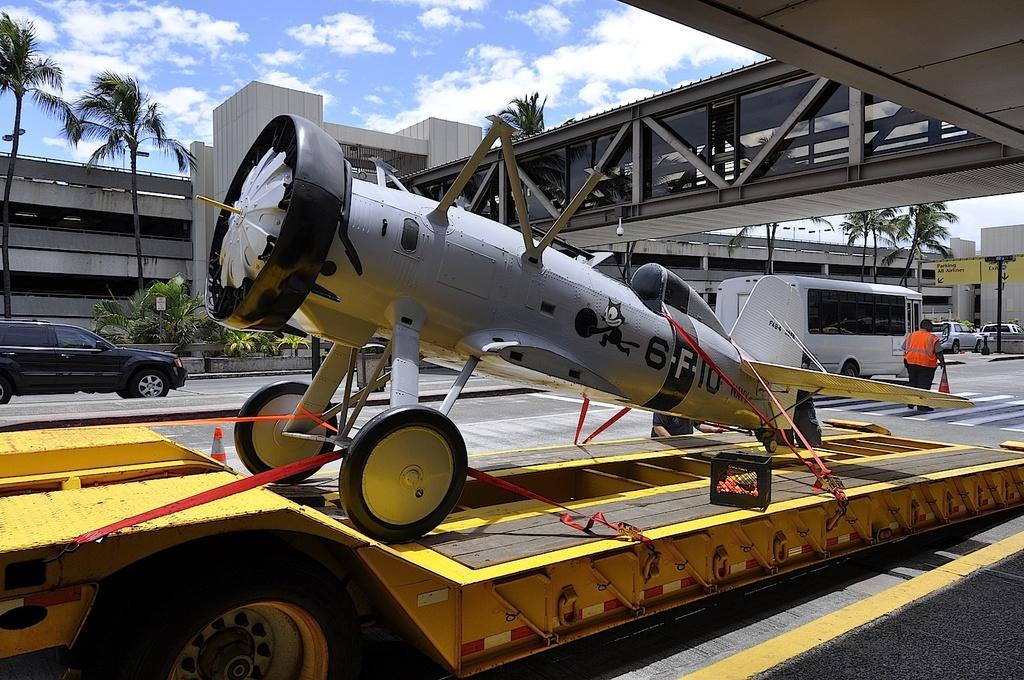<image>
Render a clear and concise summary of the photo. A tiny plane that says, "6-F-10" is tied up on a platform. 